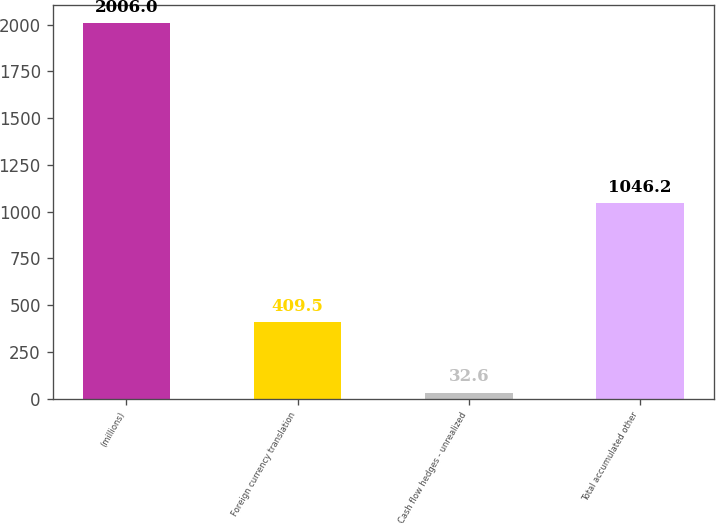<chart> <loc_0><loc_0><loc_500><loc_500><bar_chart><fcel>(millions)<fcel>Foreign currency translation<fcel>Cash flow hedges - unrealized<fcel>Total accumulated other<nl><fcel>2006<fcel>409.5<fcel>32.6<fcel>1046.2<nl></chart> 